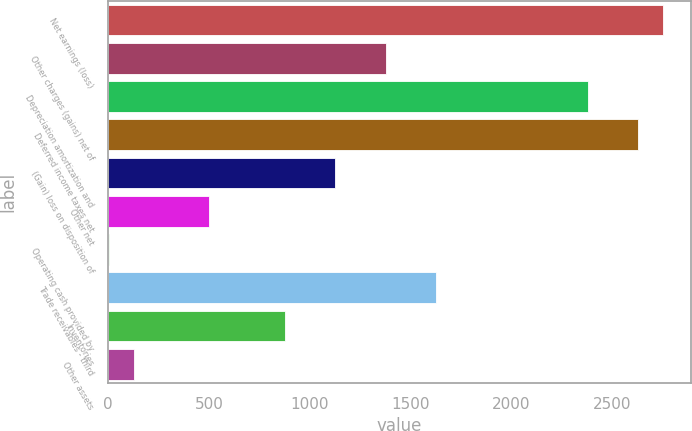<chart> <loc_0><loc_0><loc_500><loc_500><bar_chart><fcel>Net earnings (loss)<fcel>Other charges (gains) net of<fcel>Depreciation amortization and<fcel>Deferred income taxes net<fcel>(Gain) loss on disposition of<fcel>Other net<fcel>Operating cash provided by<fcel>Trade receivables - third<fcel>Inventories<fcel>Other assets<nl><fcel>2756.4<fcel>1379.2<fcel>2380.8<fcel>2631.2<fcel>1128.8<fcel>502.8<fcel>2<fcel>1629.6<fcel>878.4<fcel>127.2<nl></chart> 